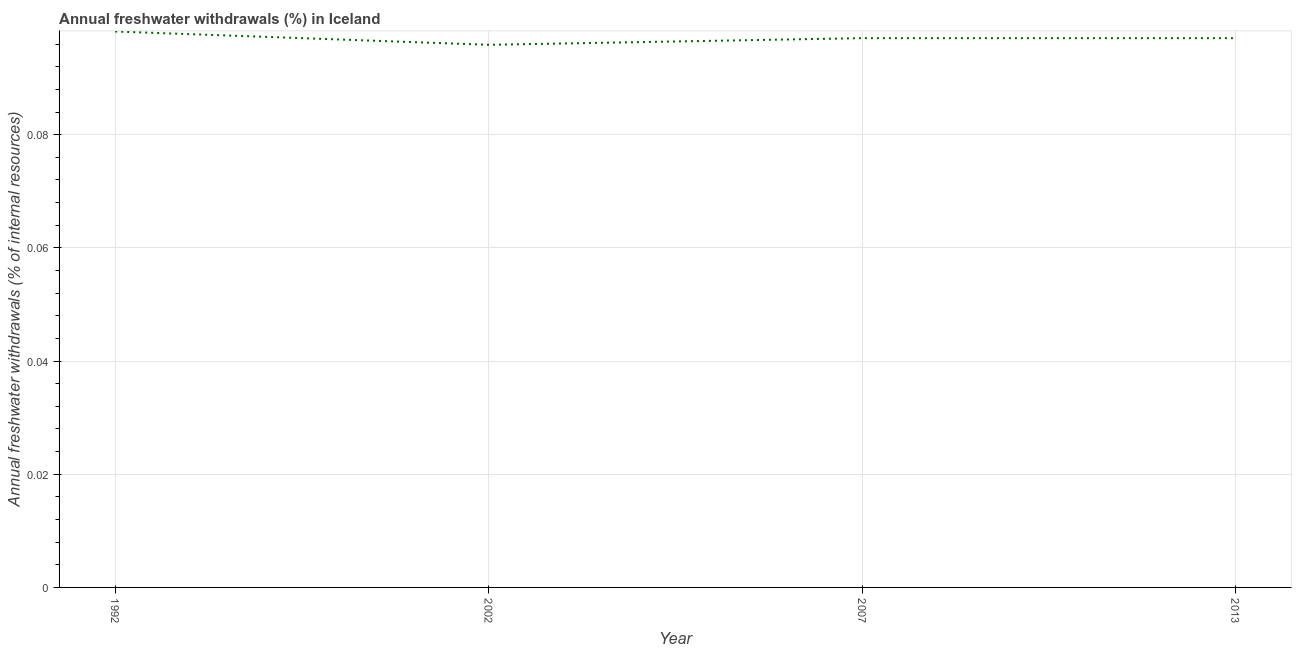What is the annual freshwater withdrawals in 2002?
Provide a succinct answer. 0.1. Across all years, what is the maximum annual freshwater withdrawals?
Provide a short and direct response. 0.1. Across all years, what is the minimum annual freshwater withdrawals?
Your response must be concise. 0.1. What is the sum of the annual freshwater withdrawals?
Give a very brief answer. 0.39. What is the difference between the annual freshwater withdrawals in 1992 and 2007?
Ensure brevity in your answer.  0. What is the average annual freshwater withdrawals per year?
Offer a very short reply. 0.1. What is the median annual freshwater withdrawals?
Provide a succinct answer. 0.1. What is the ratio of the annual freshwater withdrawals in 1992 to that in 2007?
Your response must be concise. 1.01. What is the difference between the highest and the second highest annual freshwater withdrawals?
Ensure brevity in your answer.  0. What is the difference between the highest and the lowest annual freshwater withdrawals?
Ensure brevity in your answer.  0. Does the annual freshwater withdrawals monotonically increase over the years?
Make the answer very short. No. How many years are there in the graph?
Offer a terse response. 4. Does the graph contain any zero values?
Make the answer very short. No. What is the title of the graph?
Your answer should be compact. Annual freshwater withdrawals (%) in Iceland. What is the label or title of the Y-axis?
Ensure brevity in your answer.  Annual freshwater withdrawals (% of internal resources). What is the Annual freshwater withdrawals (% of internal resources) of 1992?
Make the answer very short. 0.1. What is the Annual freshwater withdrawals (% of internal resources) in 2002?
Offer a very short reply. 0.1. What is the Annual freshwater withdrawals (% of internal resources) in 2007?
Give a very brief answer. 0.1. What is the Annual freshwater withdrawals (% of internal resources) of 2013?
Your answer should be compact. 0.1. What is the difference between the Annual freshwater withdrawals (% of internal resources) in 1992 and 2002?
Your response must be concise. 0. What is the difference between the Annual freshwater withdrawals (% of internal resources) in 1992 and 2007?
Offer a terse response. 0. What is the difference between the Annual freshwater withdrawals (% of internal resources) in 1992 and 2013?
Offer a very short reply. 0. What is the difference between the Annual freshwater withdrawals (% of internal resources) in 2002 and 2007?
Keep it short and to the point. -0. What is the difference between the Annual freshwater withdrawals (% of internal resources) in 2002 and 2013?
Provide a short and direct response. -0. What is the ratio of the Annual freshwater withdrawals (% of internal resources) in 1992 to that in 2002?
Offer a terse response. 1.02. What is the ratio of the Annual freshwater withdrawals (% of internal resources) in 1992 to that in 2007?
Your answer should be very brief. 1.01. What is the ratio of the Annual freshwater withdrawals (% of internal resources) in 1992 to that in 2013?
Provide a short and direct response. 1.01. 